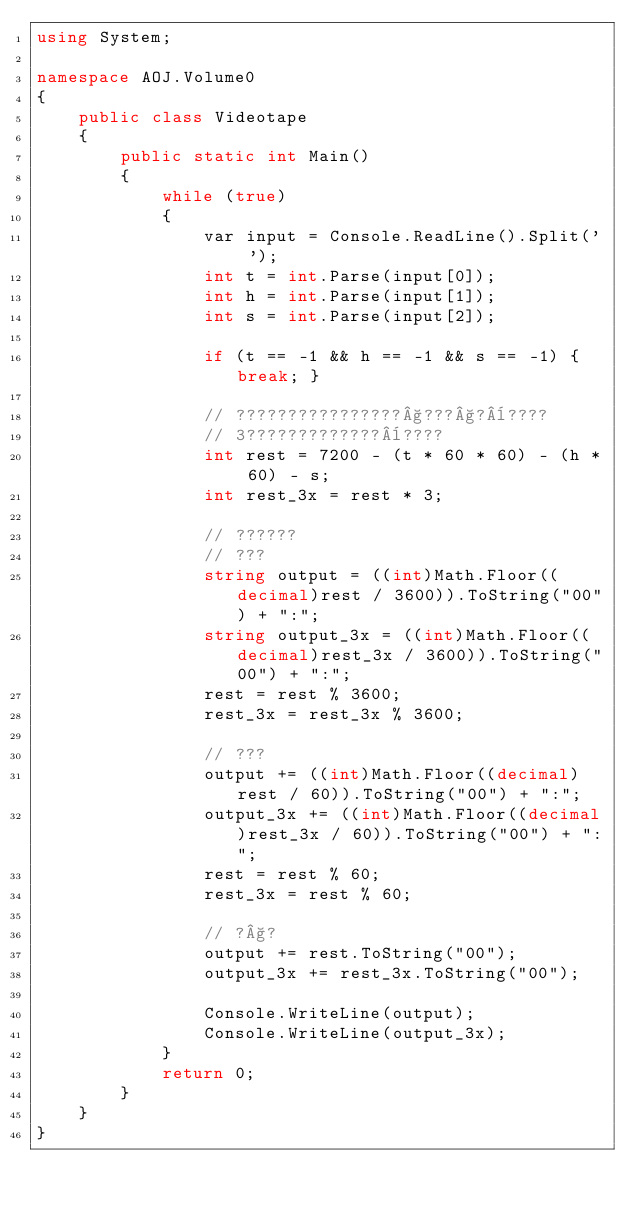Convert code to text. <code><loc_0><loc_0><loc_500><loc_500><_C#_>using System;

namespace AOJ.Volume0
{
    public class Videotape
    {
        public static int Main()
        {
            while (true)
            {
                var input = Console.ReadLine().Split(' ');
                int t = int.Parse(input[0]);
                int h = int.Parse(input[1]);
                int s = int.Parse(input[2]);

                if (t == -1 && h == -1 && s == -1) { break; }

                // ????????????????§???§?¨????
                // 3?????????????¨????
                int rest = 7200 - (t * 60 * 60) - (h * 60) - s;
                int rest_3x = rest * 3;

                // ??????
                // ???
                string output = ((int)Math.Floor((decimal)rest / 3600)).ToString("00") + ":";
                string output_3x = ((int)Math.Floor((decimal)rest_3x / 3600)).ToString("00") + ":";
                rest = rest % 3600;
                rest_3x = rest_3x % 3600;

                // ???
                output += ((int)Math.Floor((decimal)rest / 60)).ToString("00") + ":";
                output_3x += ((int)Math.Floor((decimal)rest_3x / 60)).ToString("00") + ":";
                rest = rest % 60;
                rest_3x = rest % 60;

                // ?§?
                output += rest.ToString("00");
                output_3x += rest_3x.ToString("00");

                Console.WriteLine(output);
                Console.WriteLine(output_3x);
            }
            return 0;
        }
    }
}</code> 